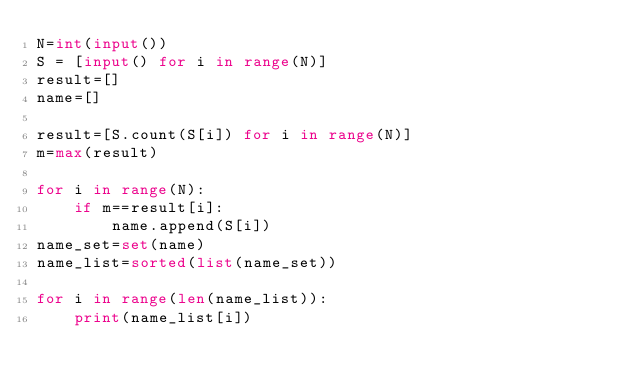Convert code to text. <code><loc_0><loc_0><loc_500><loc_500><_Python_>N=int(input())
S = [input() for i in range(N)]
result=[]
name=[]

result=[S.count(S[i]) for i in range(N)]
m=max(result)

for i in range(N):
    if m==result[i]:
        name.append(S[i])
name_set=set(name)
name_list=sorted(list(name_set))

for i in range(len(name_list)):
    print(name_list[i])</code> 